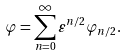Convert formula to latex. <formula><loc_0><loc_0><loc_500><loc_500>\varphi = \sum _ { n = 0 } ^ { \infty } \varepsilon ^ { n / 2 } \varphi _ { n / 2 } .</formula> 